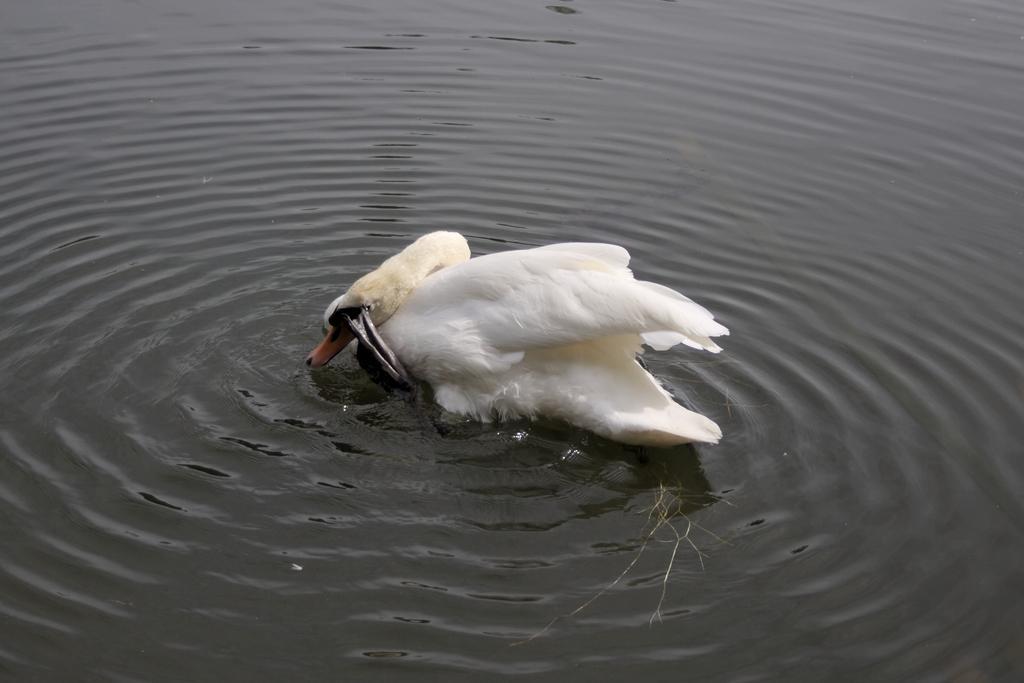Describe this image in one or two sentences. In this image I can see water and in it I can see two white colour swans. 